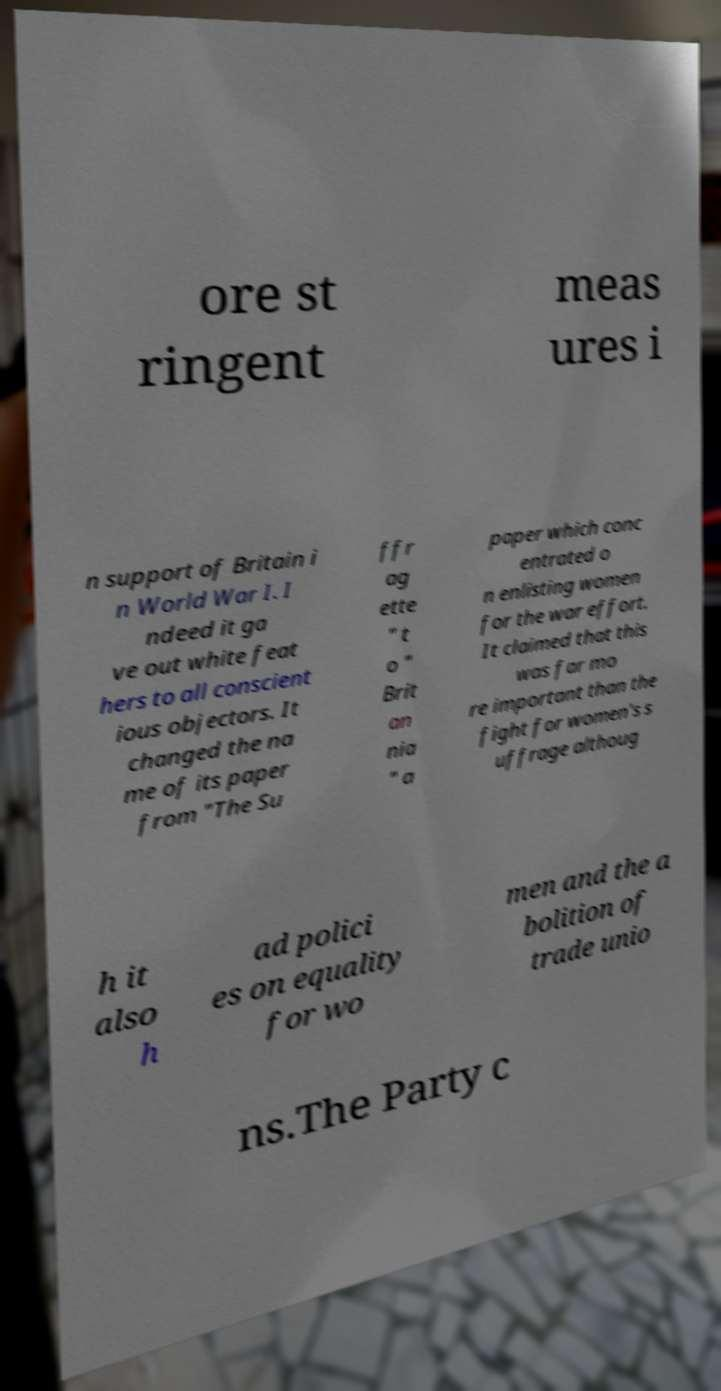Can you accurately transcribe the text from the provided image for me? ore st ringent meas ures i n support of Britain i n World War I. I ndeed it ga ve out white feat hers to all conscient ious objectors. It changed the na me of its paper from "The Su ffr ag ette " t o " Brit an nia " a paper which conc entrated o n enlisting women for the war effort. It claimed that this was far mo re important than the fight for women's s uffrage althoug h it also h ad polici es on equality for wo men and the a bolition of trade unio ns.The Party c 